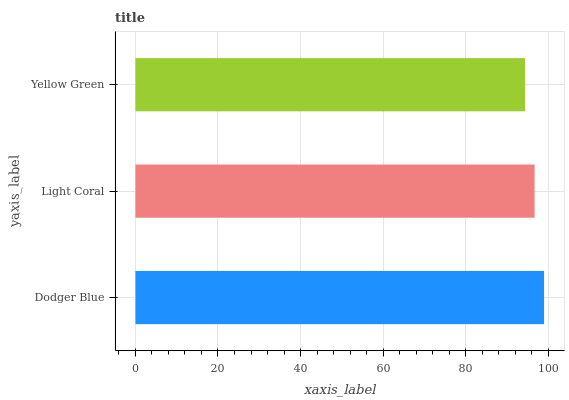Is Yellow Green the minimum?
Answer yes or no. Yes. Is Dodger Blue the maximum?
Answer yes or no. Yes. Is Light Coral the minimum?
Answer yes or no. No. Is Light Coral the maximum?
Answer yes or no. No. Is Dodger Blue greater than Light Coral?
Answer yes or no. Yes. Is Light Coral less than Dodger Blue?
Answer yes or no. Yes. Is Light Coral greater than Dodger Blue?
Answer yes or no. No. Is Dodger Blue less than Light Coral?
Answer yes or no. No. Is Light Coral the high median?
Answer yes or no. Yes. Is Light Coral the low median?
Answer yes or no. Yes. Is Yellow Green the high median?
Answer yes or no. No. Is Yellow Green the low median?
Answer yes or no. No. 